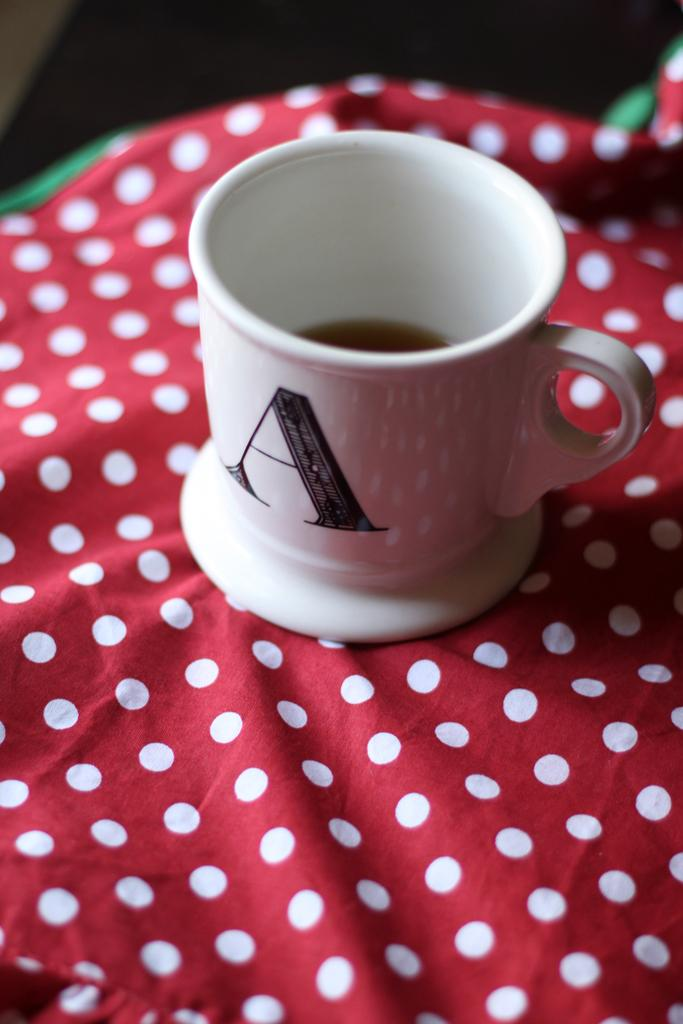<image>
Render a clear and concise summary of the photo. a cup with the letter A on it and a white handle 